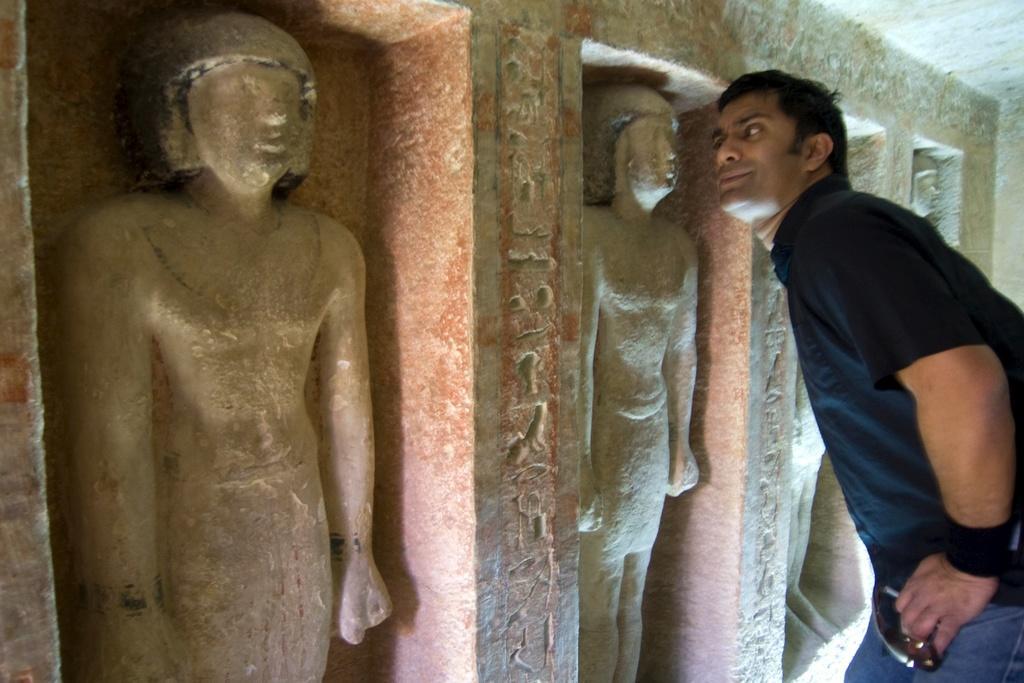Please provide a concise description of this image. In this image we can see some sculptures and a man standing beside them. 